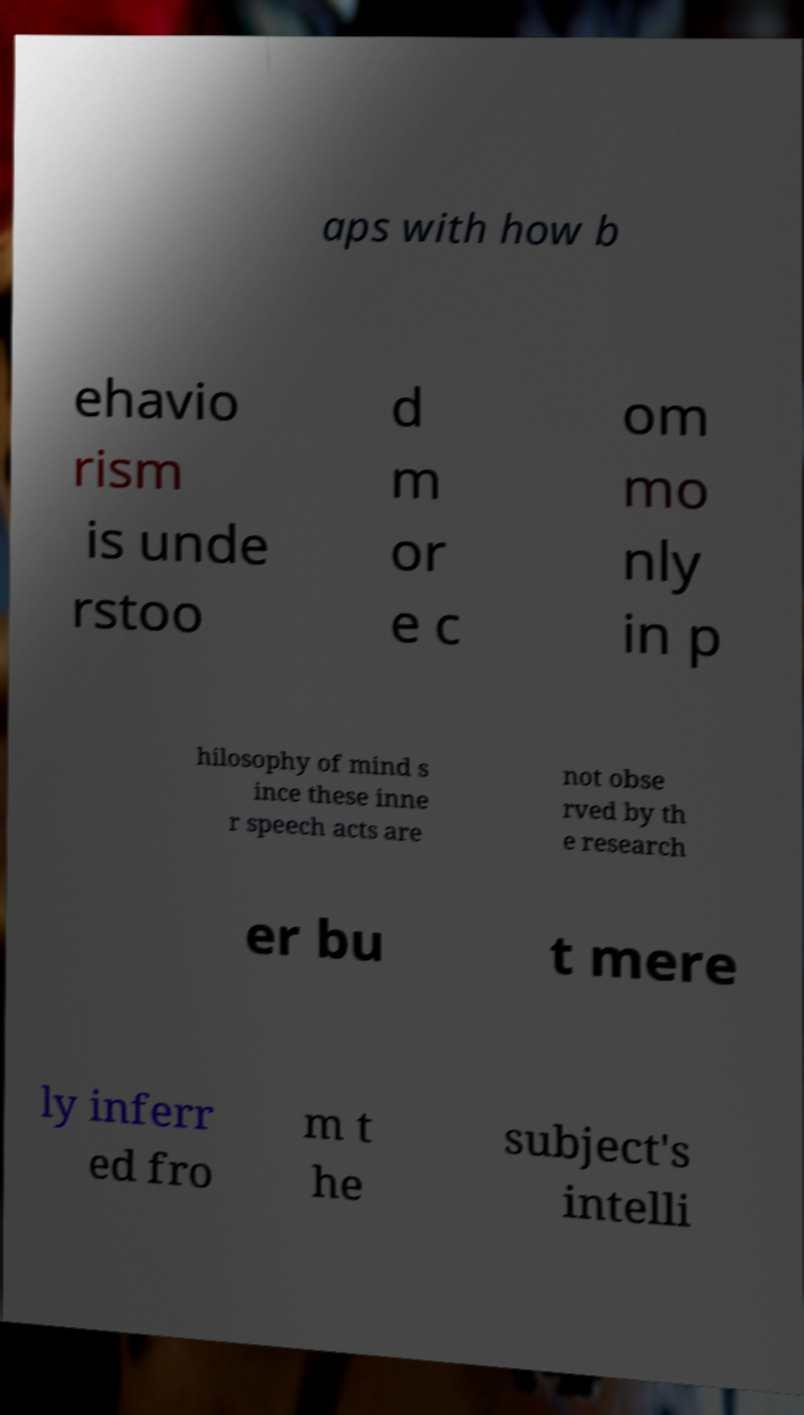What messages or text are displayed in this image? I need them in a readable, typed format. aps with how b ehavio rism is unde rstoo d m or e c om mo nly in p hilosophy of mind s ince these inne r speech acts are not obse rved by th e research er bu t mere ly inferr ed fro m t he subject's intelli 